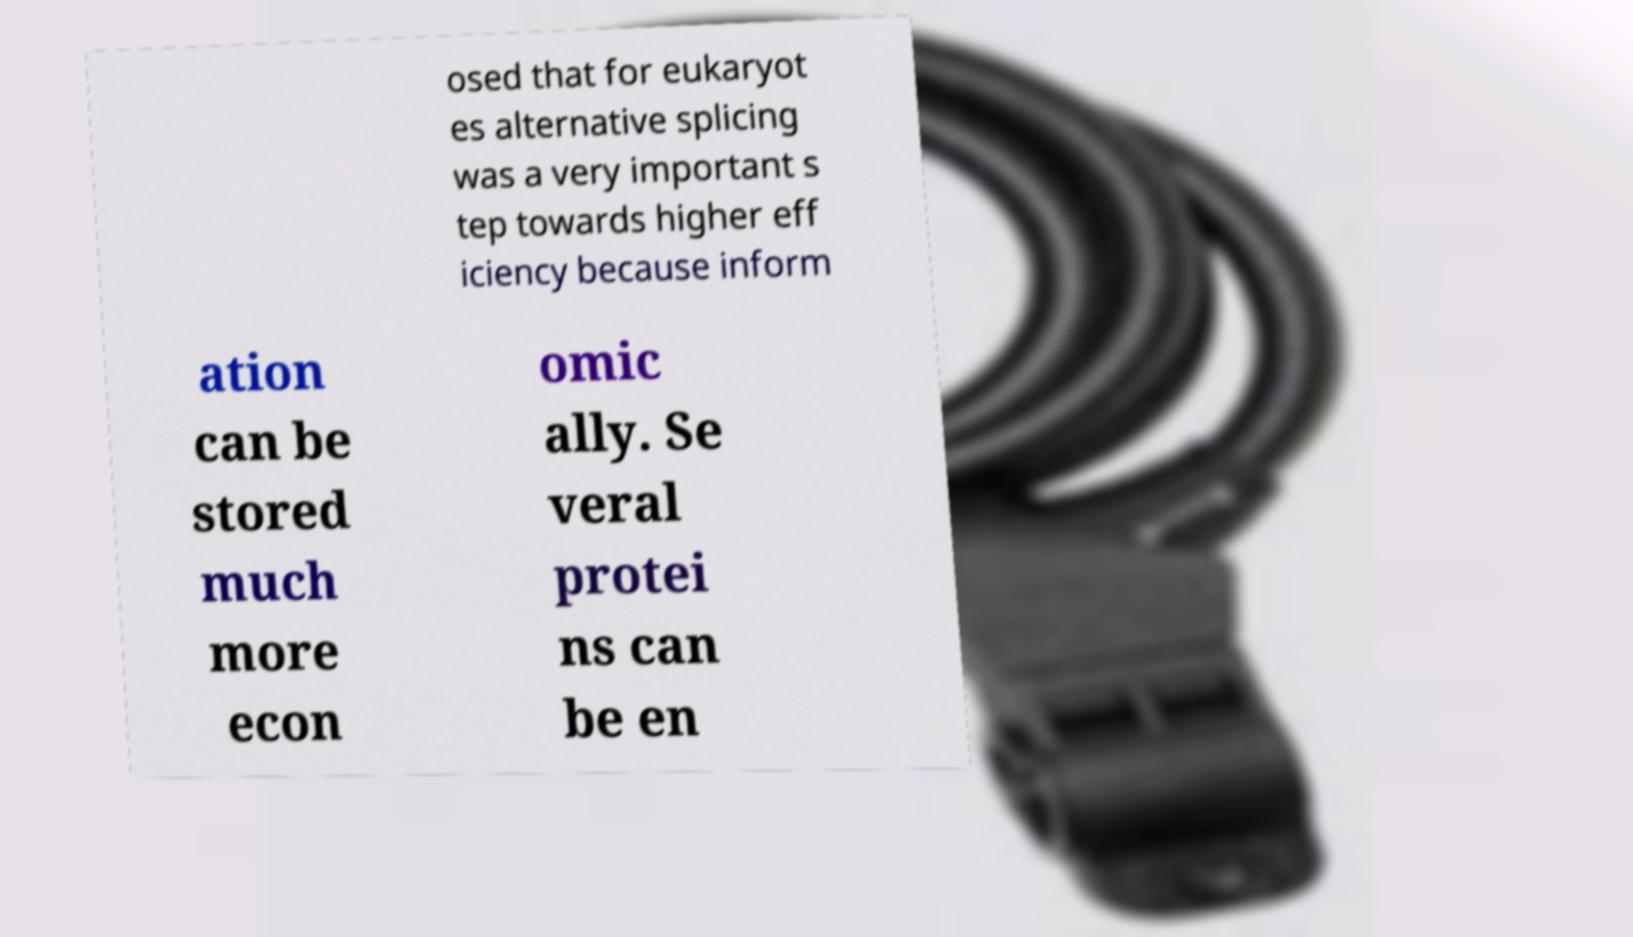Please identify and transcribe the text found in this image. osed that for eukaryot es alternative splicing was a very important s tep towards higher eff iciency because inform ation can be stored much more econ omic ally. Se veral protei ns can be en 